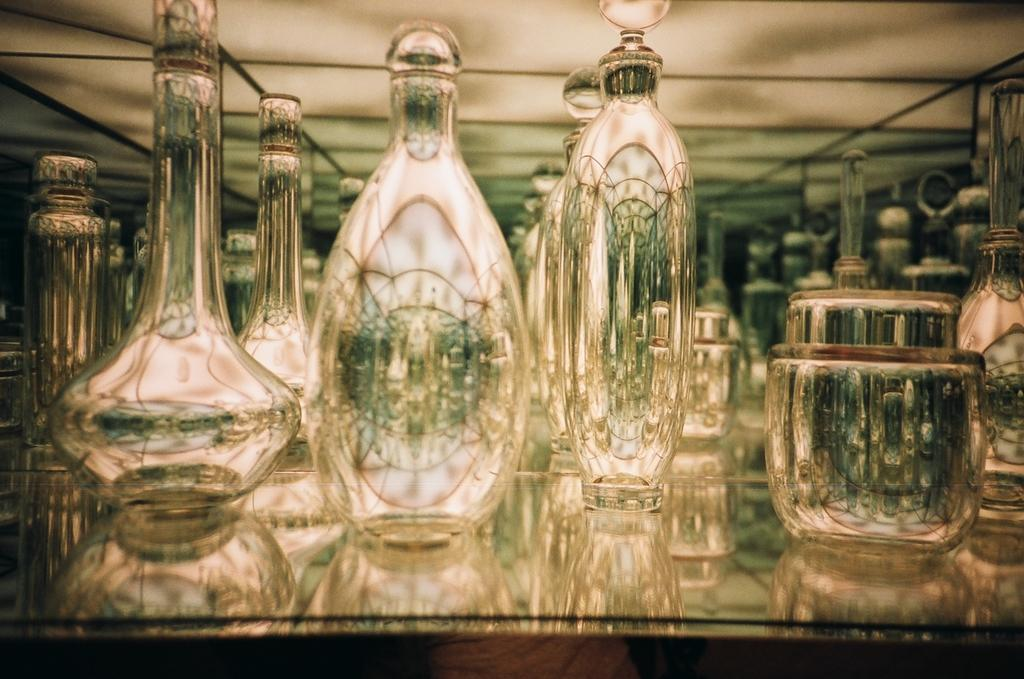What type of containers are visible in the image? There are glasses and bottles in the image. Can you describe the contents of these containers? The contents of the containers are not visible in the image. What type of army is depicted in the image? There is no army present in the image; it only features glasses and bottles. How does the range of the glasses affect the image? The range of the glasses does not affect the image, as the image only shows their presence and not their functionality. 